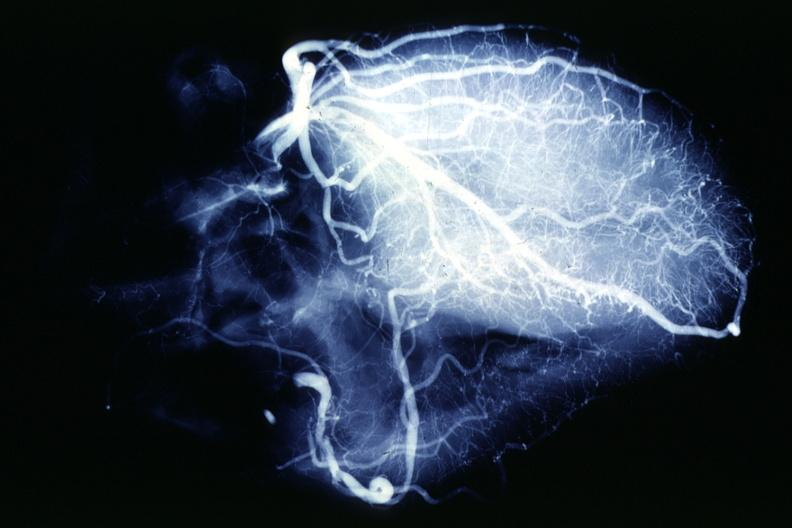what is present?
Answer the question using a single word or phrase. Coronary atherosclerosis 